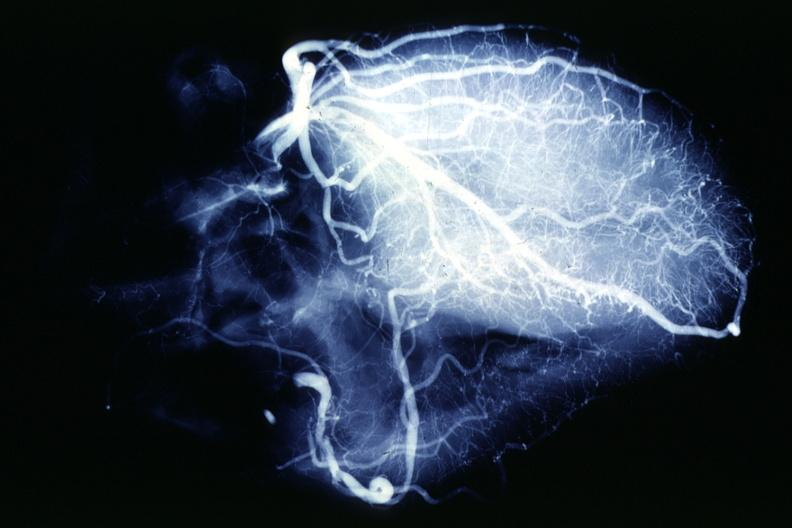what is present?
Answer the question using a single word or phrase. Coronary atherosclerosis 